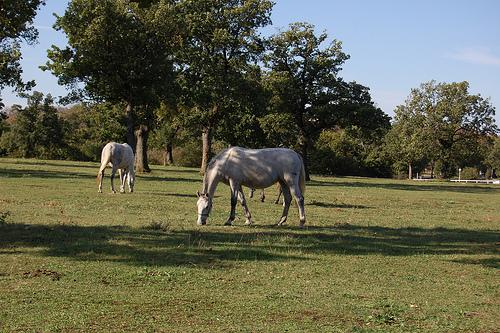Question: what are the horse doing?
Choices:
A. Drinking from a trough.
B. Being brushed.
C. Looking down.
D. Galloping.
Answer with the letter. Answer: C Question: who is in the photo?
Choices:
A. Horse.
B. Cow.
C. Rabbit.
D. Goat.
Answer with the letter. Answer: A Question: how many horse are there?
Choices:
A. One.
B. Three.
C. Four.
D. Two.
Answer with the letter. Answer: D Question: what color are the horse?
Choices:
A. White.
B. Black.
C. Brown.
D. Silver.
Answer with the letter. Answer: A Question: why is it so bright?
Choices:
A. Too many lights on.
B. Sunny.
C. Light reflecting off metal.
D. Flashlight aimed at camera.
Answer with the letter. Answer: B Question: when was the photo taken?
Choices:
A. Nighttime.
B. Morning.
C. 8:15.
D. Day time.
Answer with the letter. Answer: D Question: where are the horse?
Choices:
A. The grass.
B. In a stable.
C. On a racetrack.
D. On the beach.
Answer with the letter. Answer: A 